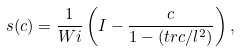<formula> <loc_0><loc_0><loc_500><loc_500>s ( c ) = \frac { 1 } { W i } \left ( I - \frac { c } { 1 - ( t r c / l ^ { 2 } ) } \right ) ,</formula> 